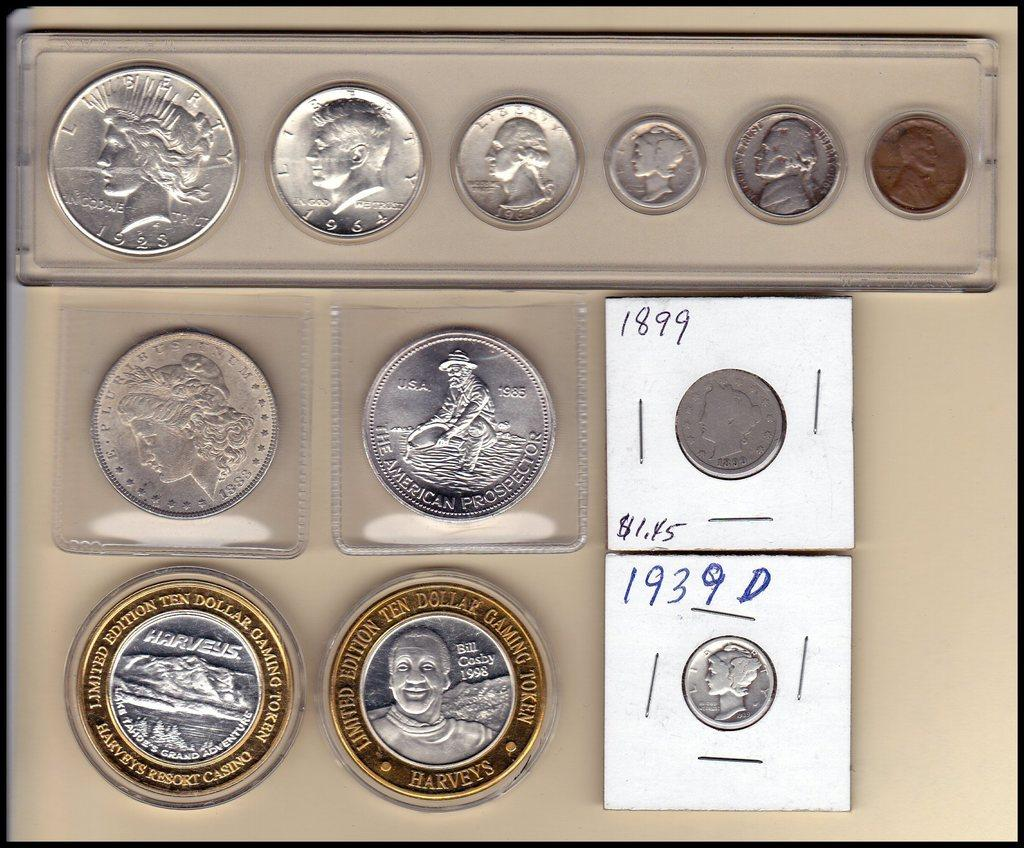Provide a one-sentence caption for the provided image. A coin collection featuring U.S. coins and a ten dollar token from Harveys. 